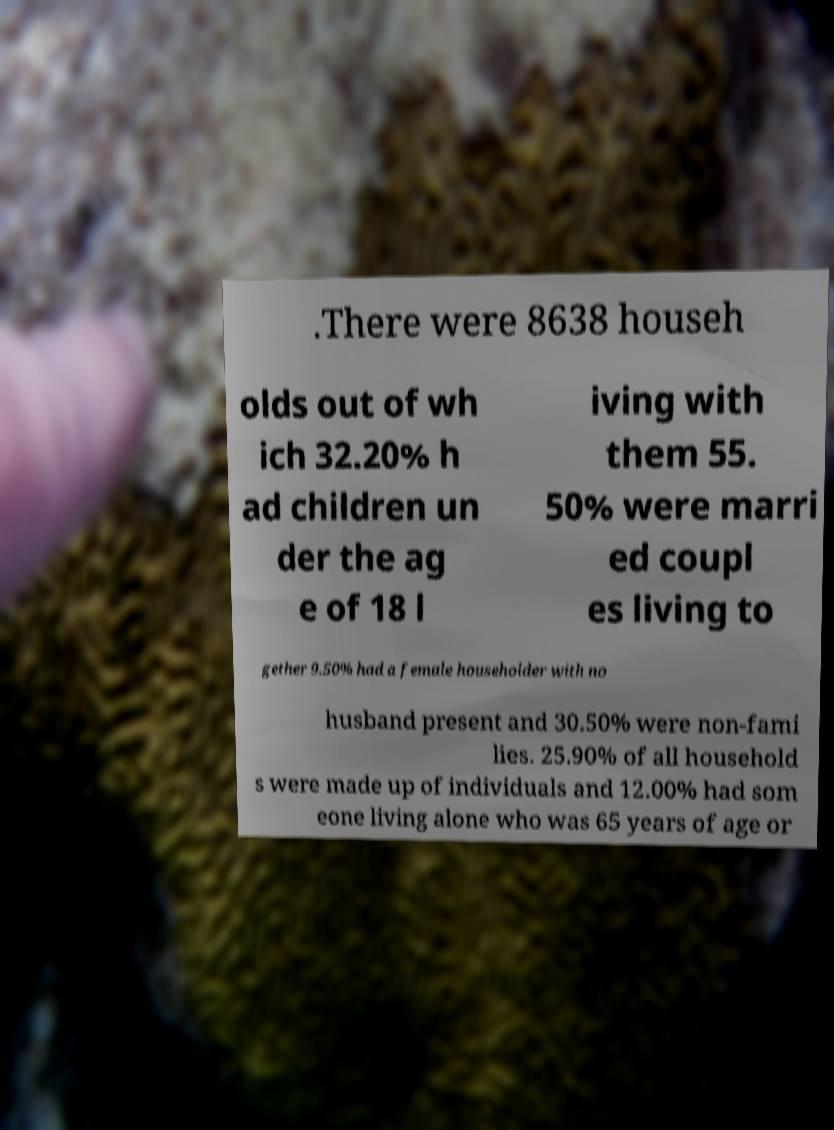There's text embedded in this image that I need extracted. Can you transcribe it verbatim? .There were 8638 househ olds out of wh ich 32.20% h ad children un der the ag e of 18 l iving with them 55. 50% were marri ed coupl es living to gether 9.50% had a female householder with no husband present and 30.50% were non-fami lies. 25.90% of all household s were made up of individuals and 12.00% had som eone living alone who was 65 years of age or 